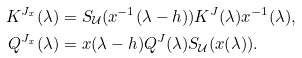Convert formula to latex. <formula><loc_0><loc_0><loc_500><loc_500>K ^ { J _ { x } } ( \lambda ) & = S _ { \mathcal { U } } ( x ^ { - 1 } ( \lambda - h ) ) K ^ { J } ( \lambda ) x ^ { - 1 } ( \lambda ) , \\ Q ^ { J _ { x } } ( \lambda ) & = x ( \lambda - h ) Q ^ { J } ( \lambda ) S _ { \mathcal { U } } ( x ( \lambda ) ) .</formula> 